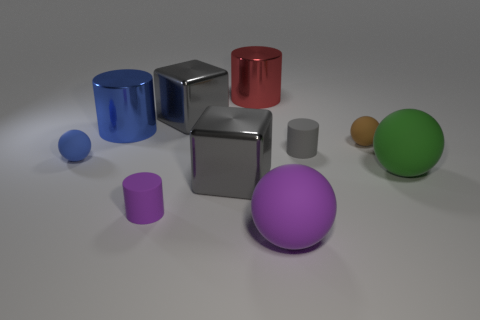What is the color of the large ball behind the big rubber sphere that is left of the big green ball?
Give a very brief answer. Green. There is another tiny matte object that is the same shape as the tiny purple thing; what is its color?
Offer a terse response. Gray. There is a blue matte thing that is the same shape as the brown matte object; what size is it?
Keep it short and to the point. Small. What is the purple object behind the large purple sphere made of?
Offer a terse response. Rubber. Are there fewer blue rubber objects right of the blue metal thing than tiny gray objects?
Keep it short and to the point. Yes. The gray shiny thing behind the thing to the right of the small brown rubber sphere is what shape?
Make the answer very short. Cube. What number of other objects are there of the same size as the purple cylinder?
Give a very brief answer. 3. There is a object that is behind the small blue sphere and left of the purple cylinder; what is its material?
Provide a short and direct response. Metal. There is a blue metal cylinder that is left of the purple cylinder; is its size the same as the tiny gray cylinder?
Make the answer very short. No. How many things are both on the left side of the gray cylinder and behind the small gray matte thing?
Make the answer very short. 3. 